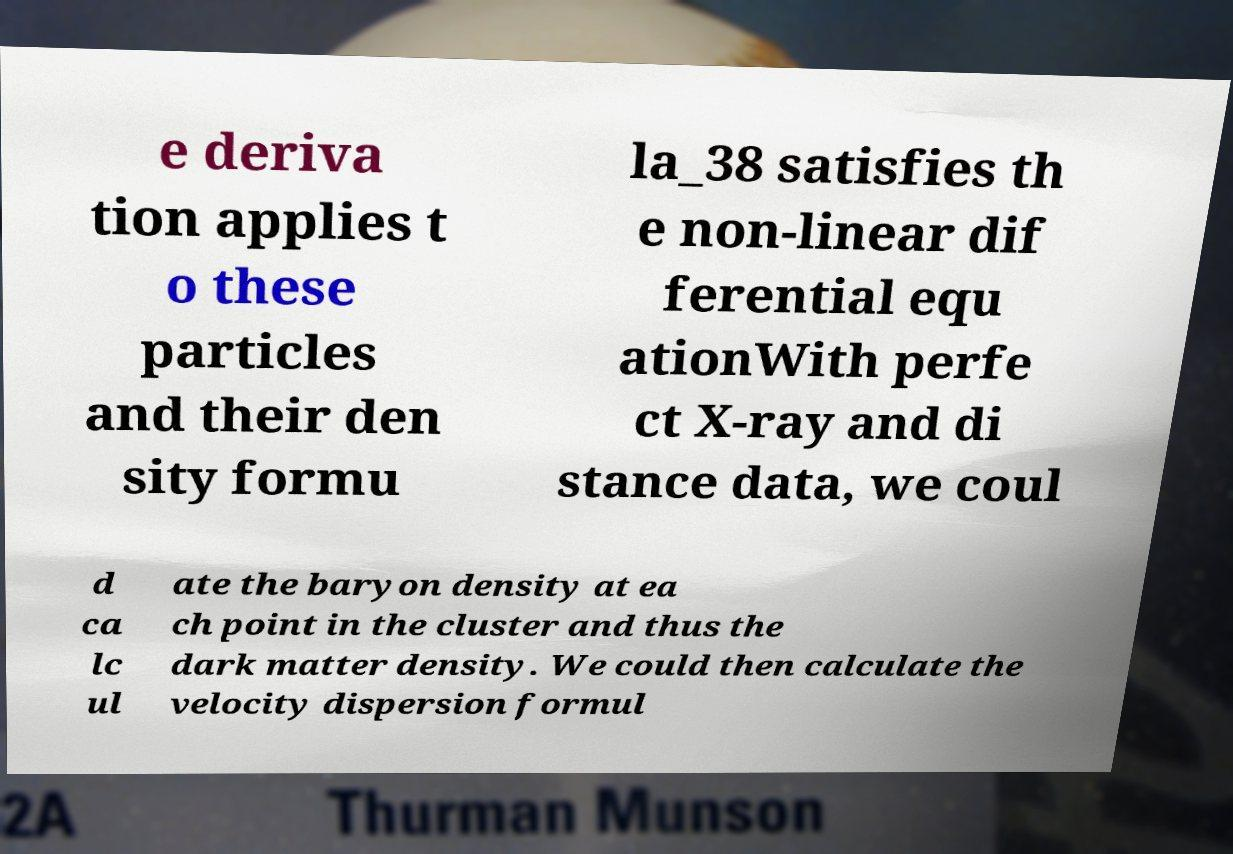Please read and relay the text visible in this image. What does it say? e deriva tion applies t o these particles and their den sity formu la_38 satisfies th e non-linear dif ferential equ ationWith perfe ct X-ray and di stance data, we coul d ca lc ul ate the baryon density at ea ch point in the cluster and thus the dark matter density. We could then calculate the velocity dispersion formul 